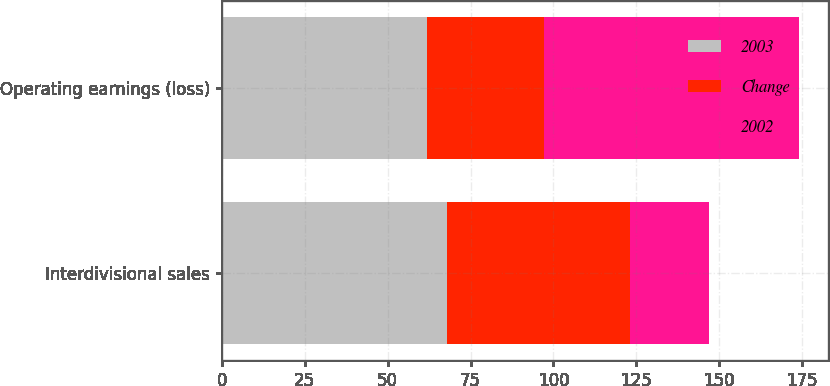<chart> <loc_0><loc_0><loc_500><loc_500><stacked_bar_chart><ecel><fcel>Interdivisional sales<fcel>Operating earnings (loss)<nl><fcel>2003<fcel>68<fcel>62<nl><fcel>Change<fcel>55<fcel>35<nl><fcel>2002<fcel>24<fcel>77<nl></chart> 